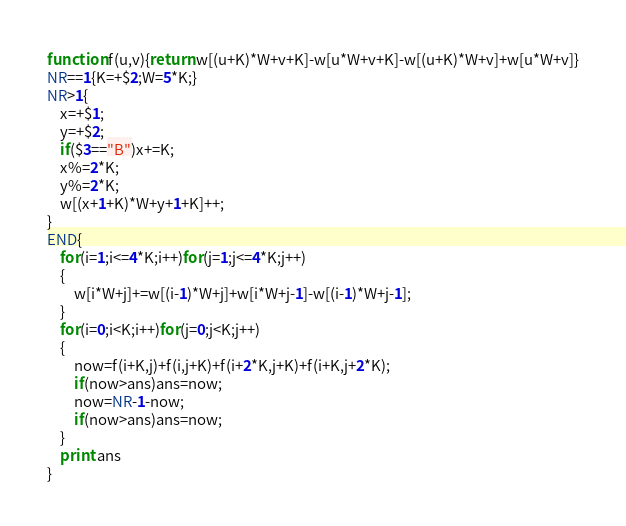Convert code to text. <code><loc_0><loc_0><loc_500><loc_500><_Awk_>function f(u,v){return w[(u+K)*W+v+K]-w[u*W+v+K]-w[(u+K)*W+v]+w[u*W+v]}
NR==1{K=+$2;W=5*K;}
NR>1{
	x=+$1;
	y=+$2;
	if($3=="B")x+=K;
	x%=2*K;
	y%=2*K;
	w[(x+1+K)*W+y+1+K]++;
}
END{
	for(i=1;i<=4*K;i++)for(j=1;j<=4*K;j++)
	{
		w[i*W+j]+=w[(i-1)*W+j]+w[i*W+j-1]-w[(i-1)*W+j-1];
	}
	for(i=0;i<K;i++)for(j=0;j<K;j++)
	{
		now=f(i+K,j)+f(i,j+K)+f(i+2*K,j+K)+f(i+K,j+2*K);
		if(now>ans)ans=now;
		now=NR-1-now;
		if(now>ans)ans=now;
	}
	print ans
}</code> 